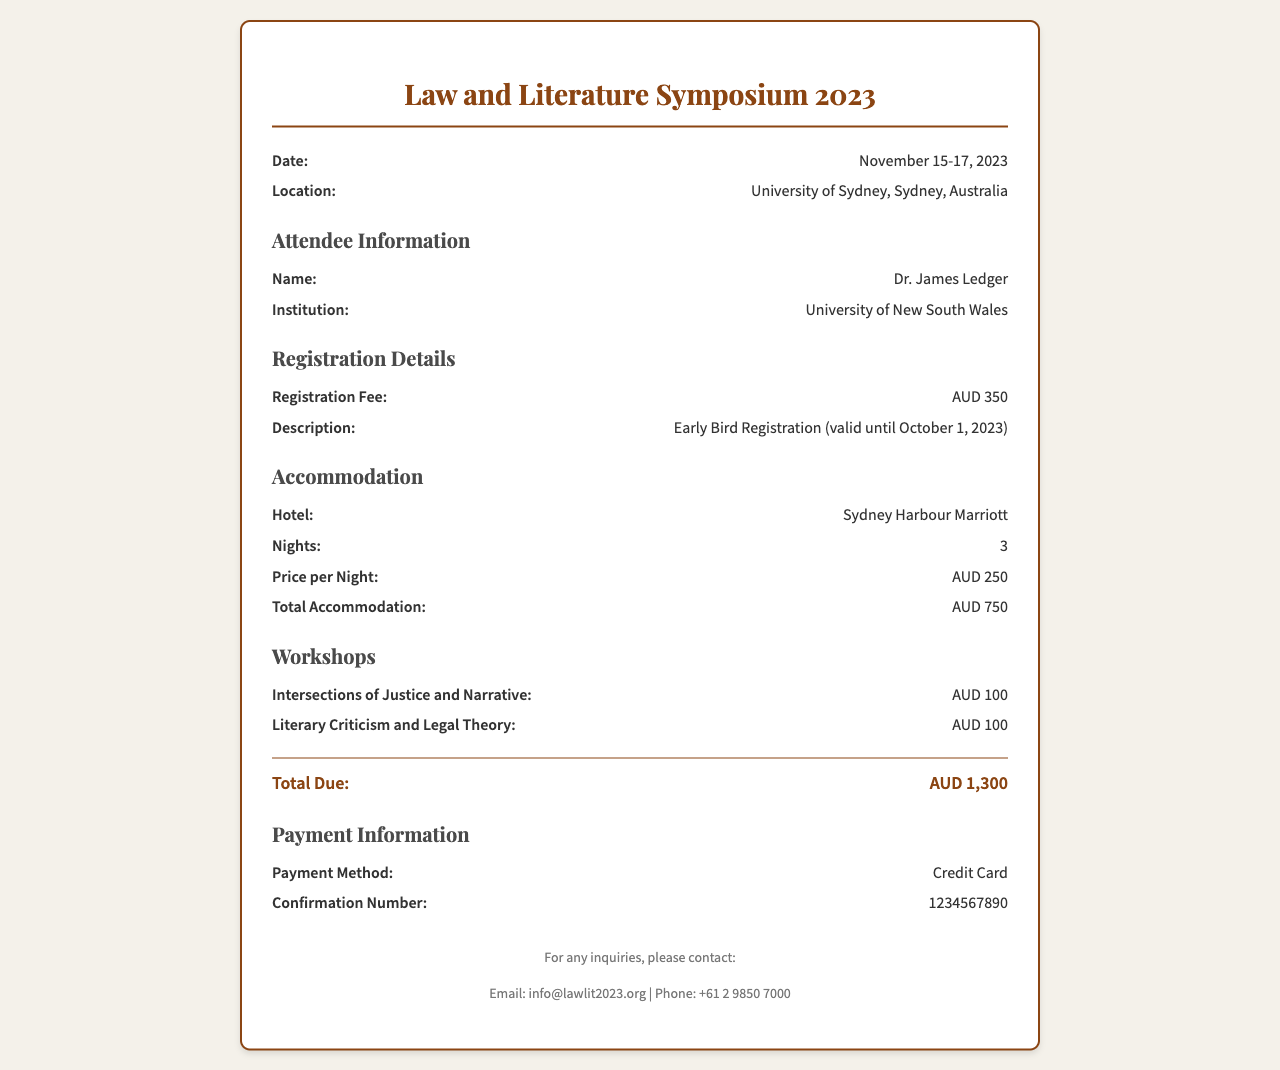What are the dates of the symposium? The dates of the symposium are mentioned in the document, which states it will be held from November 15 to November 17, 2023.
Answer: November 15-17, 2023 What is the total registration fee? The total registration fee is clearly stated in the document as AUD 350.
Answer: AUD 350 How many nights is accommodation booked for? The number of nights for accommodation is specified in the accommodation section as 3 nights.
Answer: 3 What is the price per night for the hotel? The document describes the price per night for accommodation as AUD 250.
Answer: AUD 250 What are the selected workshops? The workshops selected are listed in the document, specifically 'Intersections of Justice and Narrative' and 'Literary Criticism and Legal Theory.'
Answer: Intersections of Justice and Narrative, Literary Criticism and Legal Theory What is the total accommodation cost? The total accommodation cost is calculated and stated in the accommodation section as AUD 750.
Answer: AUD 750 How much is the fee for each workshop? The document indicates that both workshops cost AUD 100 each.
Answer: AUD 100 What is the total due amount? The total due amount is summarized at the end of the document and is AUD 1,300.
Answer: AUD 1,300 What payment method was used? The payment method is specified in the payment information section, indicating that a credit card was used.
Answer: Credit Card 